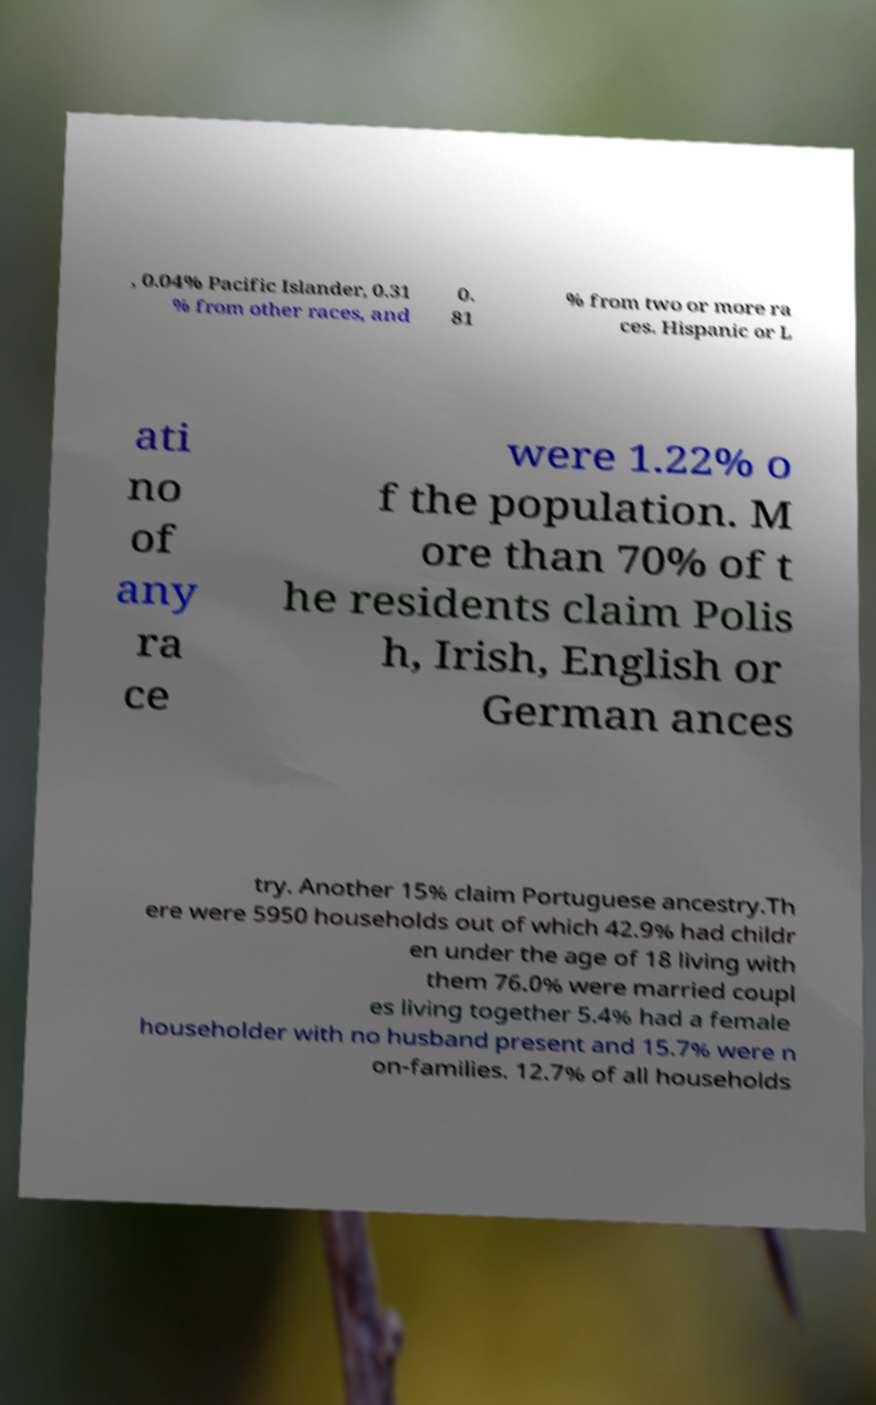Please identify and transcribe the text found in this image. , 0.04% Pacific Islander, 0.31 % from other races, and 0. 81 % from two or more ra ces. Hispanic or L ati no of any ra ce were 1.22% o f the population. M ore than 70% of t he residents claim Polis h, Irish, English or German ances try. Another 15% claim Portuguese ancestry.Th ere were 5950 households out of which 42.9% had childr en under the age of 18 living with them 76.0% were married coupl es living together 5.4% had a female householder with no husband present and 15.7% were n on-families. 12.7% of all households 